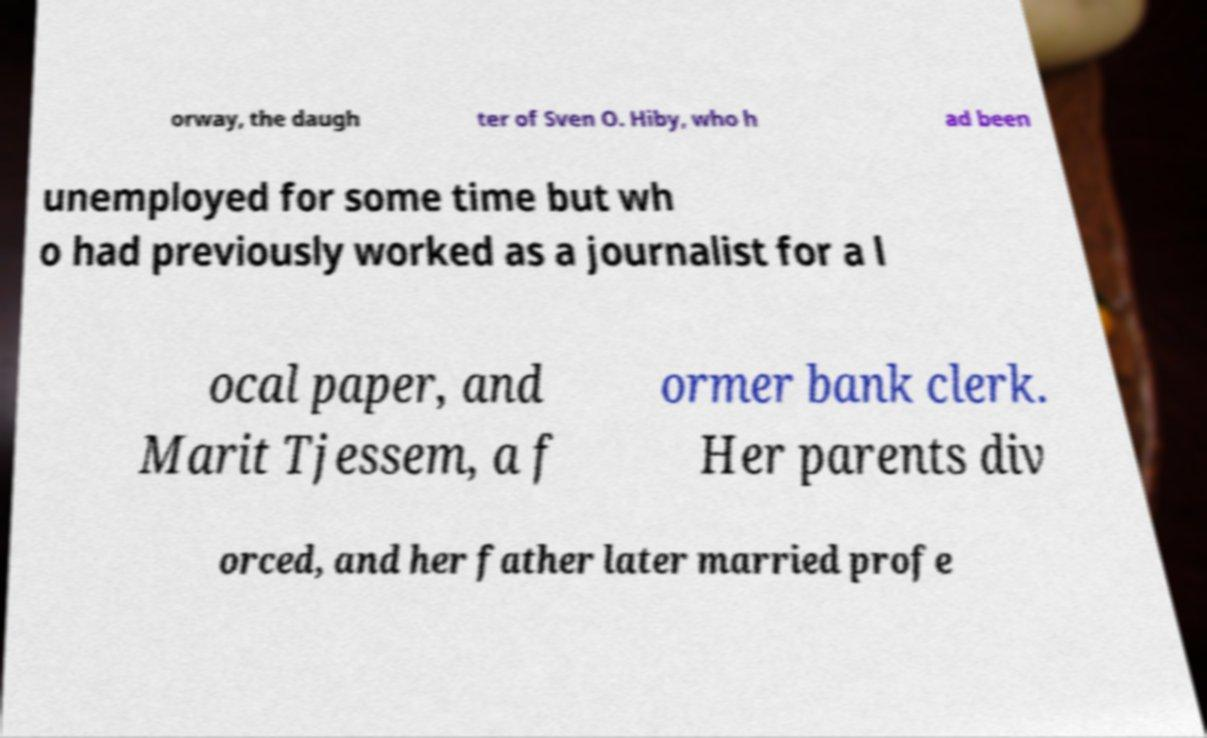For documentation purposes, I need the text within this image transcribed. Could you provide that? orway, the daugh ter of Sven O. Hiby, who h ad been unemployed for some time but wh o had previously worked as a journalist for a l ocal paper, and Marit Tjessem, a f ormer bank clerk. Her parents div orced, and her father later married profe 